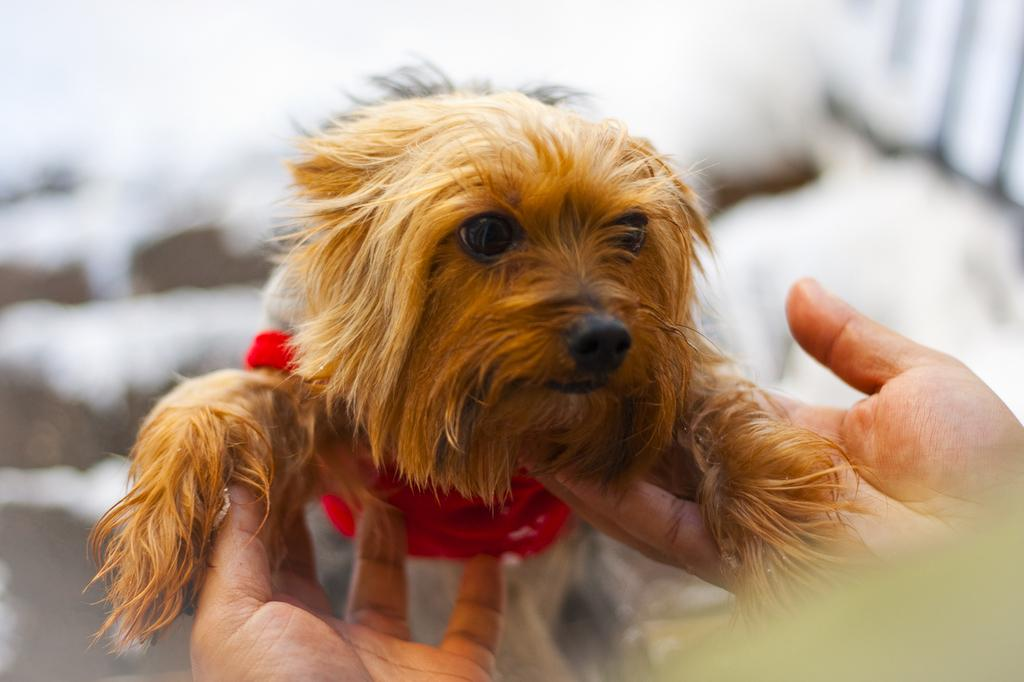What type of animal is in the image? There is a dog in the image. Where is the dog located in the image? The dog is on a person's hand. Can you describe the background of the image? The background of the image is blurred. What type of chalk is being used to draw on the ground in the image? There is no chalk or drawing on the ground present in the image; it features a dog on a person's hand with a blurred background. 